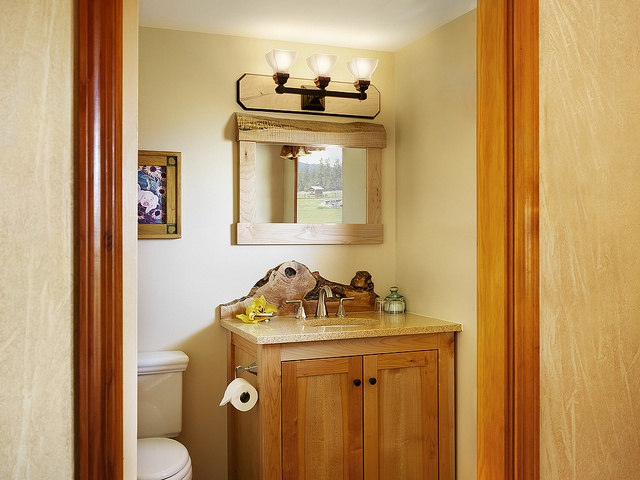Describe the objects in this image and their specific colors. I can see toilet in tan, gray, darkgray, and lightgray tones and sink in tan and olive tones in this image. 